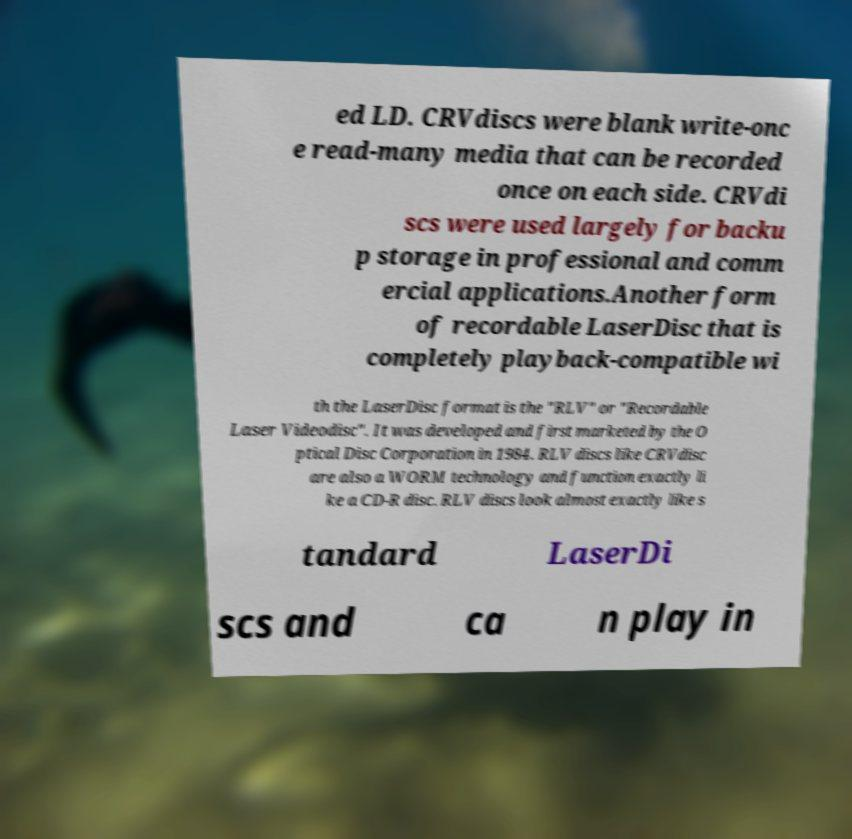There's text embedded in this image that I need extracted. Can you transcribe it verbatim? ed LD. CRVdiscs were blank write-onc e read-many media that can be recorded once on each side. CRVdi scs were used largely for backu p storage in professional and comm ercial applications.Another form of recordable LaserDisc that is completely playback-compatible wi th the LaserDisc format is the "RLV" or "Recordable Laser Videodisc". It was developed and first marketed by the O ptical Disc Corporation in 1984. RLV discs like CRVdisc are also a WORM technology and function exactly li ke a CD-R disc. RLV discs look almost exactly like s tandard LaserDi scs and ca n play in 